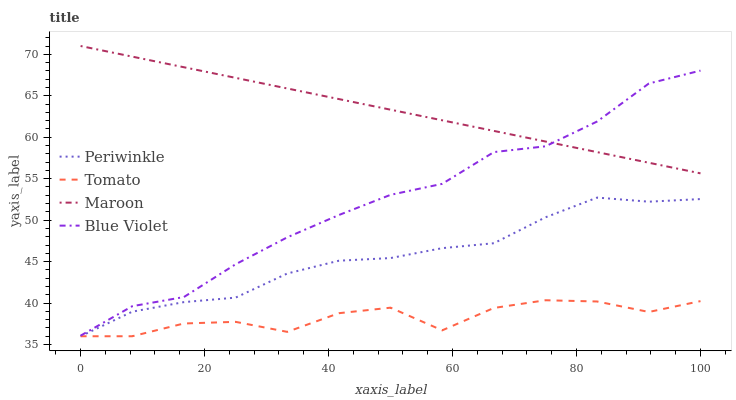Does Tomato have the minimum area under the curve?
Answer yes or no. Yes. Does Periwinkle have the minimum area under the curve?
Answer yes or no. No. Does Periwinkle have the maximum area under the curve?
Answer yes or no. No. Is Tomato the roughest?
Answer yes or no. Yes. Is Periwinkle the smoothest?
Answer yes or no. No. Is Periwinkle the roughest?
Answer yes or no. No. Does Blue Violet have the lowest value?
Answer yes or no. No. Does Periwinkle have the highest value?
Answer yes or no. No. Is Periwinkle less than Maroon?
Answer yes or no. Yes. Is Maroon greater than Periwinkle?
Answer yes or no. Yes. Does Periwinkle intersect Maroon?
Answer yes or no. No. 